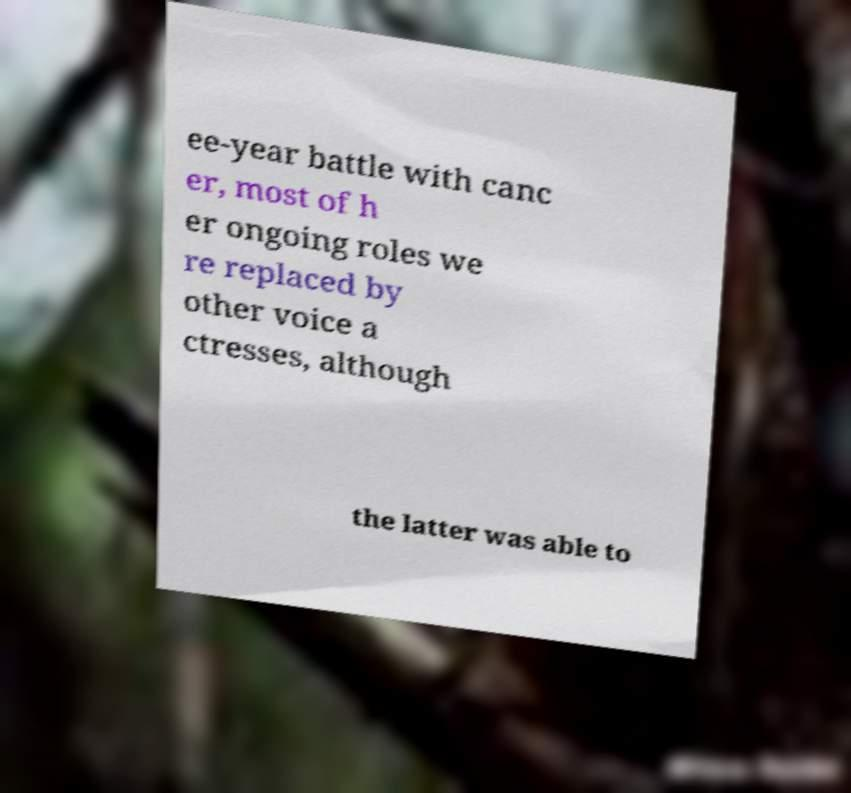Please identify and transcribe the text found in this image. ee-year battle with canc er, most of h er ongoing roles we re replaced by other voice a ctresses, although the latter was able to 